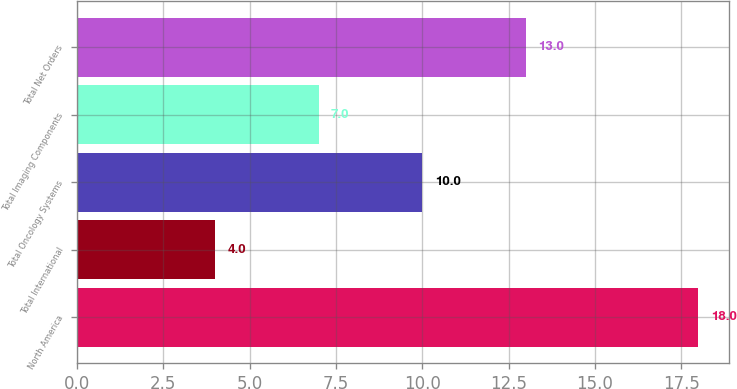Convert chart. <chart><loc_0><loc_0><loc_500><loc_500><bar_chart><fcel>North America<fcel>Total International<fcel>Total Oncology Systems<fcel>Total Imaging Components<fcel>Total Net Orders<nl><fcel>18<fcel>4<fcel>10<fcel>7<fcel>13<nl></chart> 